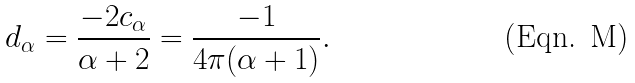<formula> <loc_0><loc_0><loc_500><loc_500>d _ { \alpha } = \frac { - 2 c _ { \alpha } } { \alpha + 2 } = \frac { - 1 } { 4 \pi ( \alpha + 1 ) } .</formula> 